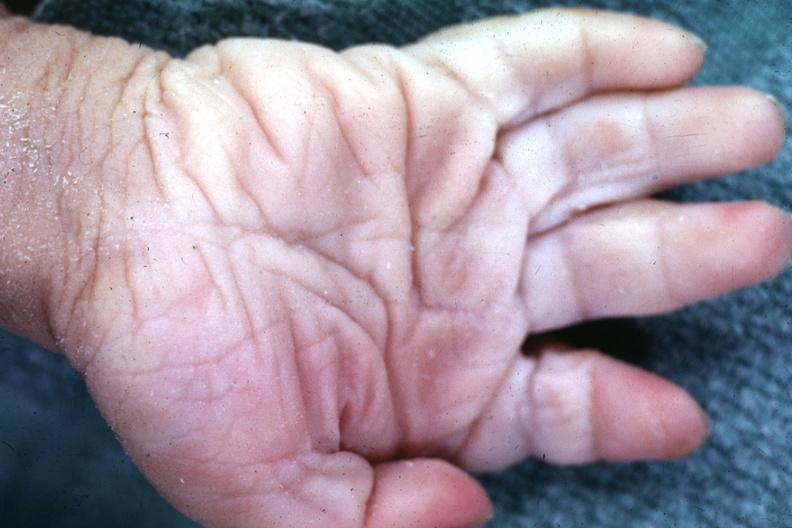re extremities present?
Answer the question using a single word or phrase. Yes 